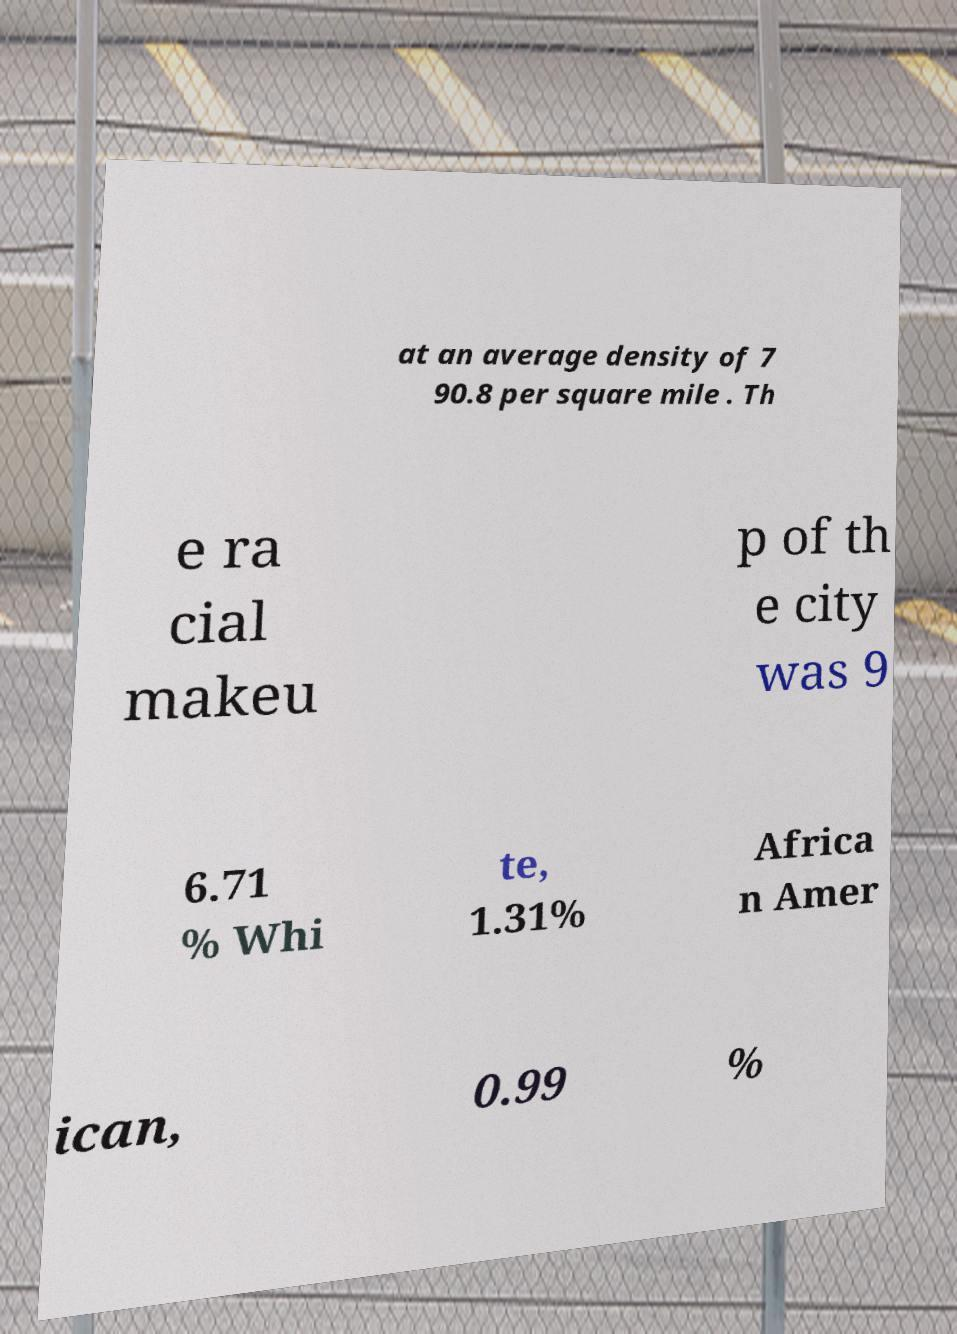Can you accurately transcribe the text from the provided image for me? at an average density of 7 90.8 per square mile . Th e ra cial makeu p of th e city was 9 6.71 % Whi te, 1.31% Africa n Amer ican, 0.99 % 